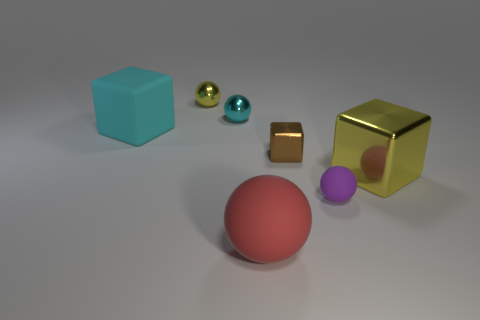What size is the ball that is the same color as the large matte cube?
Your answer should be very brief. Small. Is there a tiny metal cube that has the same color as the large rubber block?
Make the answer very short. No. There is a purple ball that is the same material as the red thing; what is its size?
Give a very brief answer. Small. Is the material of the large cyan cube the same as the yellow sphere?
Ensure brevity in your answer.  No. There is a large cube in front of the matte thing that is left of the yellow metallic thing to the left of the red thing; what is its color?
Provide a short and direct response. Yellow. What is the shape of the big red thing?
Offer a terse response. Sphere. Does the large shiny block have the same color as the large object that is in front of the big yellow shiny thing?
Offer a terse response. No. Are there an equal number of small yellow balls that are behind the tiny rubber object and big gray rubber objects?
Make the answer very short. No. How many yellow metallic cylinders have the same size as the red object?
Ensure brevity in your answer.  0. Are any small red objects visible?
Ensure brevity in your answer.  No. 